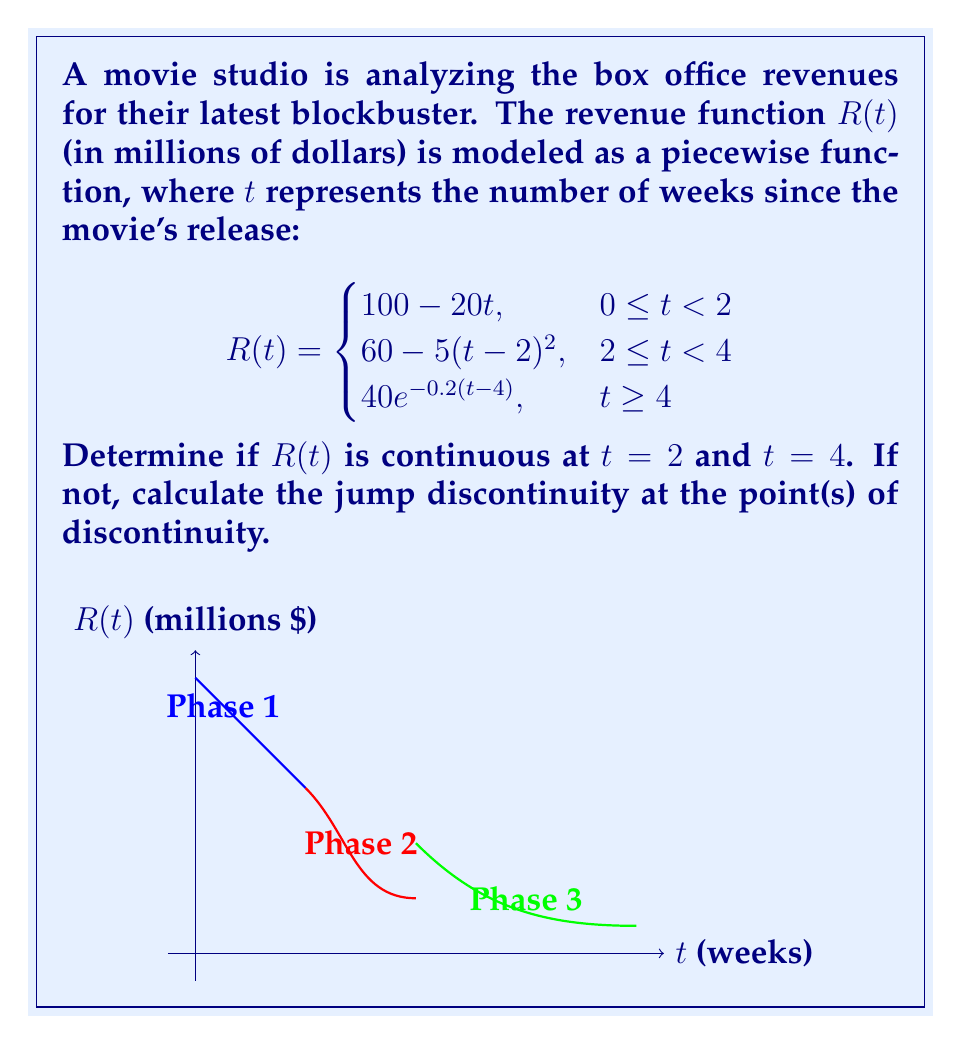Help me with this question. To determine continuity at $t = 2$ and $t = 4$, we need to check three conditions at each point:
1. The function is defined at the point
2. The limit of the function as we approach the point from both sides exists
3. The limit equals the function value at that point

For $t = 2$:

1. $R(2)$ is defined in both pieces of the function.
2. Left-hand limit: 
   $\lim_{t \to 2^-} R(t) = \lim_{t \to 2^-} (100 - 20t) = 60$
   Right-hand limit:
   $\lim_{t \to 2^+} R(t) = \lim_{t \to 2^+} (60 - 5(t-2)^2) = 60$
3. $R(2) = 60$ (from the second piece of the function)

All three conditions are met, so $R(t)$ is continuous at $t = 2$.

For $t = 4$:

1. $R(4)$ is defined in both pieces of the function.
2. Left-hand limit:
   $\lim_{t \to 4^-} R(t) = \lim_{t \to 4^-} (60 - 5(t-2)^2) = 20$
   Right-hand limit:
   $\lim_{t \to 4^+} R(t) = \lim_{t \to 4^+} (40e^{-0.2(t-4)}) = 40$
3. $R(4) = 40$ (from the third piece of the function)

The left-hand limit doesn't equal the right-hand limit, so $R(t)$ is not continuous at $t = 4$.

The jump discontinuity at $t = 4$ is:
$\lim_{t \to 4^+} R(t) - \lim_{t \to 4^-} R(t) = 40 - 20 = 20$ million dollars.
Answer: Continuous at $t = 2$; discontinuous at $t = 4$ with a jump of $20$ million dollars. 